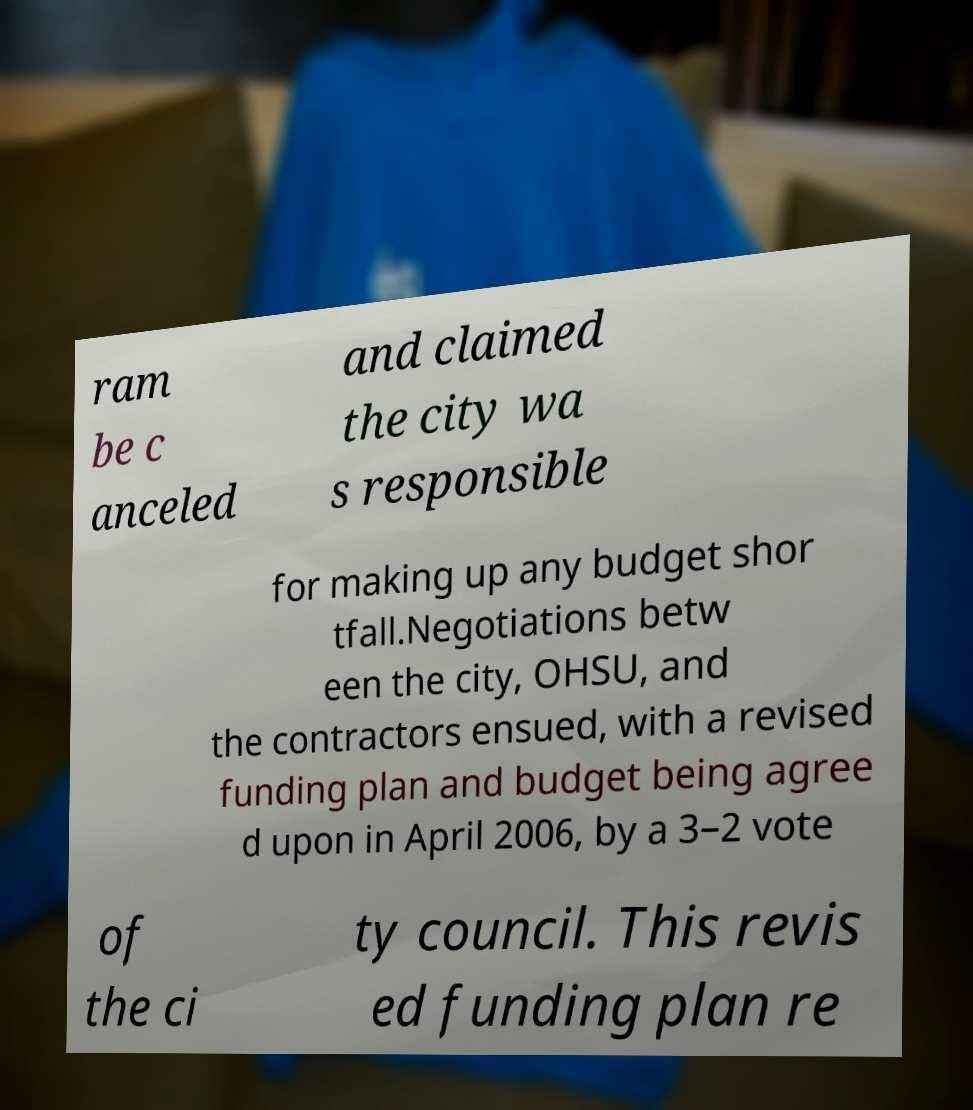Could you extract and type out the text from this image? ram be c anceled and claimed the city wa s responsible for making up any budget shor tfall.Negotiations betw een the city, OHSU, and the contractors ensued, with a revised funding plan and budget being agree d upon in April 2006, by a 3–2 vote of the ci ty council. This revis ed funding plan re 